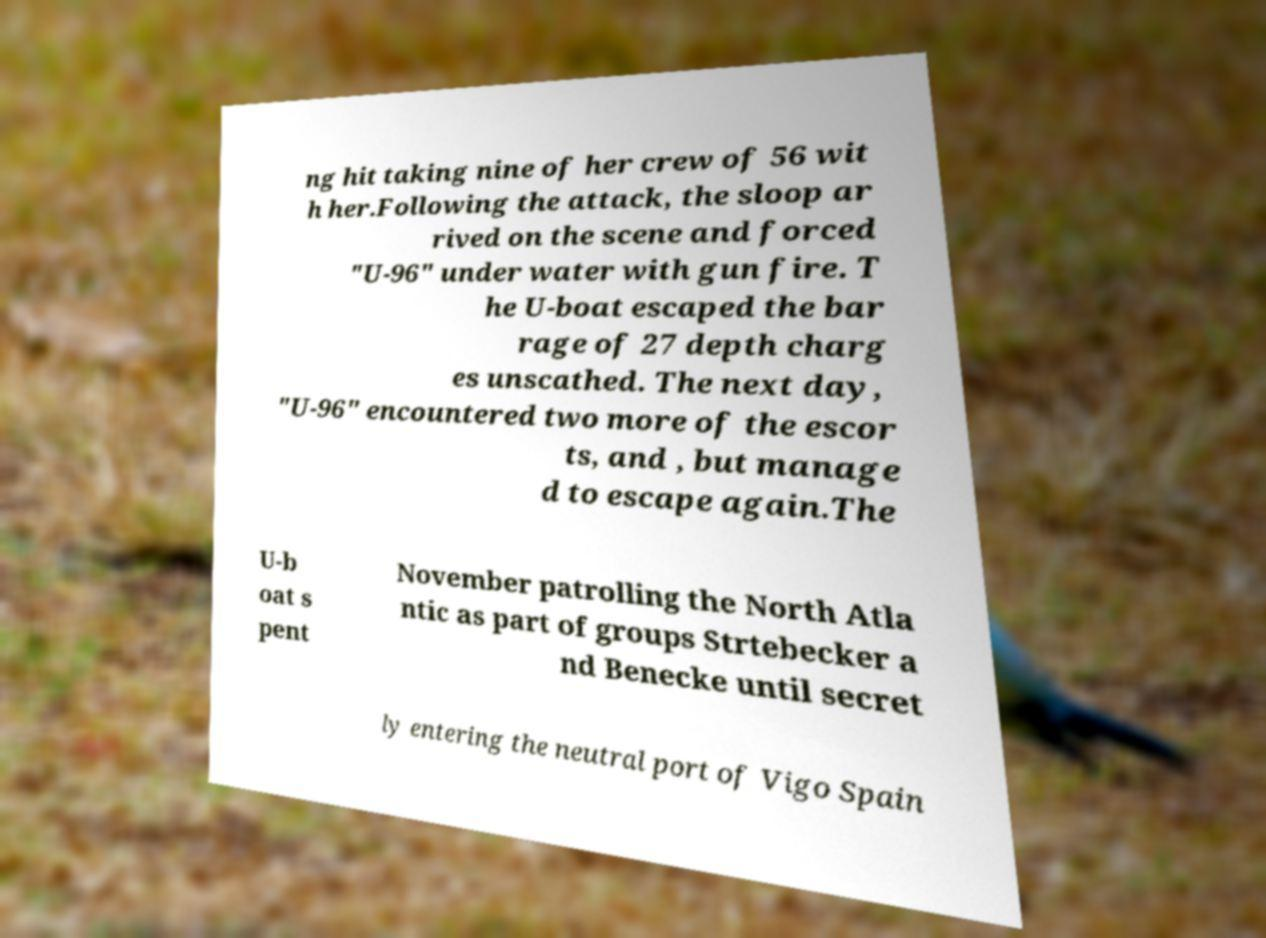I need the written content from this picture converted into text. Can you do that? ng hit taking nine of her crew of 56 wit h her.Following the attack, the sloop ar rived on the scene and forced "U-96" under water with gun fire. T he U-boat escaped the bar rage of 27 depth charg es unscathed. The next day, "U-96" encountered two more of the escor ts, and , but manage d to escape again.The U-b oat s pent November patrolling the North Atla ntic as part of groups Strtebecker a nd Benecke until secret ly entering the neutral port of Vigo Spain 